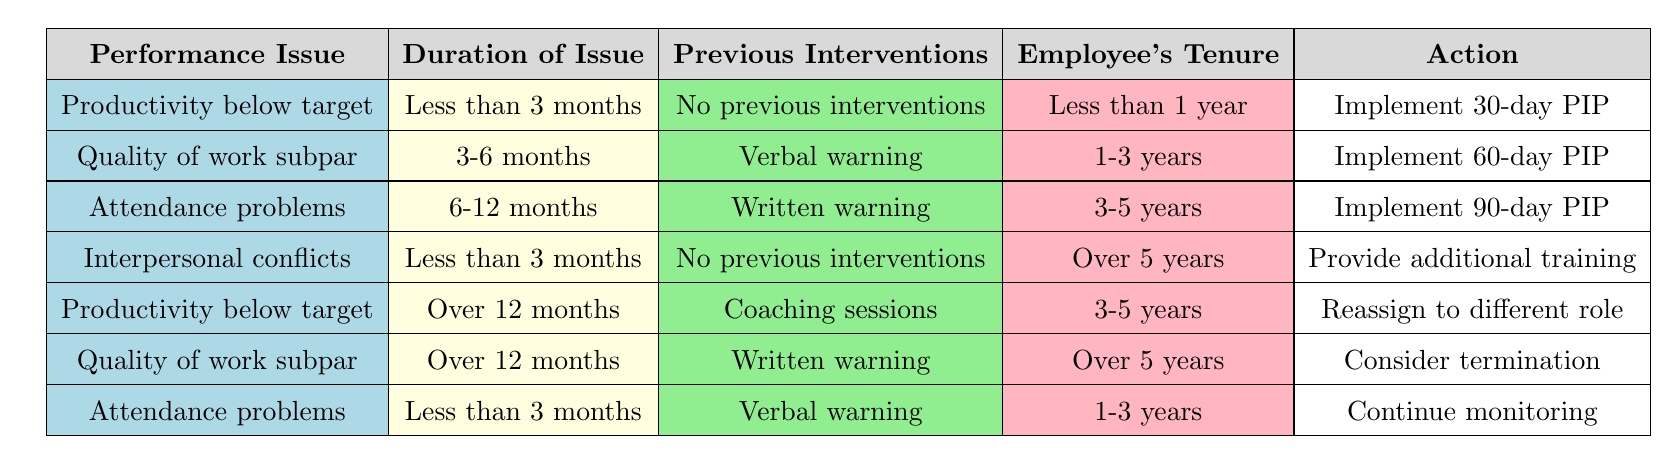What action is recommended for an employee with attendance problems lasting less than 3 months who has received a verbal warning and has 1-3 years of tenure? According to the table, for "Attendance problems" with "Less than 3 months," "Verbal warning," and "1-3 years" of tenure, the action specified is "Continue monitoring."
Answer: Continue monitoring What action should be taken for an employee with productivity issues lasting over 12 months who has received coaching sessions and has a tenure of 3-5 years? Based on the table, an employee with "Productivity below target," "Over 12 months," "Coaching sessions," and "3-5 years" of tenure should be "Reassigned to different role."
Answer: Reassign to different role Does the table recommend a 30-day performance improvement plan for an employee with less than 1 year of tenure experiencing productivity issues with no previous interventions? Yes, according to the table for "Productivity below target," "Less than 3 months," "No previous interventions," and "Less than 1 year," the recommended action is to "Implement 30-day PIP."
Answer: Yes What factors lead to considering termination for an employee with quality issues over 12 months and more than 5 years of tenure? The table specifies that if the employee has "Quality of work subpar," "Over 12 months," "Written warning," and "Over 5 years," the action to be taken is "Consider termination."
Answer: Quality of work subpar, Over 12 months, Written warning, Over 5 years How many actions in the table involve providing additional training? Reviewing the table, only one condition leads to "Provide additional training," which is for "Interpersonal conflicts," "Less than 3 months," "No previous interventions," and "Over 5 years." Therefore, the count is one action.
Answer: 1 What is the average tenure of employees who are advised to implement a 90-day performance improvement plan based on their attendance problems? Looking at the table, there is one instance for a 90-day PIP which is for "Attendance problems," "6-12 months," "Written warning," and "3-5 years." Thus, the average tenure considering this single case will be 4 years.
Answer: 4 years 